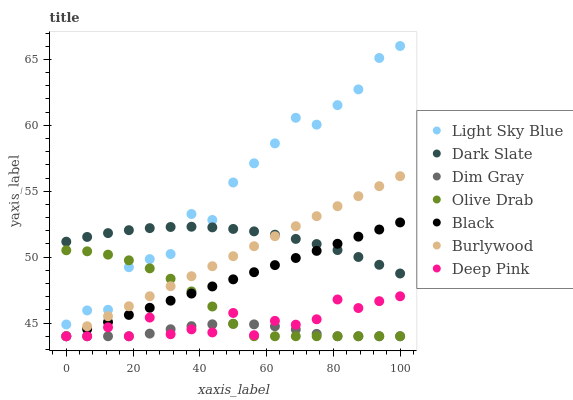Does Dim Gray have the minimum area under the curve?
Answer yes or no. Yes. Does Light Sky Blue have the maximum area under the curve?
Answer yes or no. Yes. Does Burlywood have the minimum area under the curve?
Answer yes or no. No. Does Burlywood have the maximum area under the curve?
Answer yes or no. No. Is Black the smoothest?
Answer yes or no. Yes. Is Light Sky Blue the roughest?
Answer yes or no. Yes. Is Burlywood the smoothest?
Answer yes or no. No. Is Burlywood the roughest?
Answer yes or no. No. Does Dim Gray have the lowest value?
Answer yes or no. Yes. Does Dark Slate have the lowest value?
Answer yes or no. No. Does Light Sky Blue have the highest value?
Answer yes or no. Yes. Does Burlywood have the highest value?
Answer yes or no. No. Is Black less than Light Sky Blue?
Answer yes or no. Yes. Is Dark Slate greater than Olive Drab?
Answer yes or no. Yes. Does Deep Pink intersect Dim Gray?
Answer yes or no. Yes. Is Deep Pink less than Dim Gray?
Answer yes or no. No. Is Deep Pink greater than Dim Gray?
Answer yes or no. No. Does Black intersect Light Sky Blue?
Answer yes or no. No. 